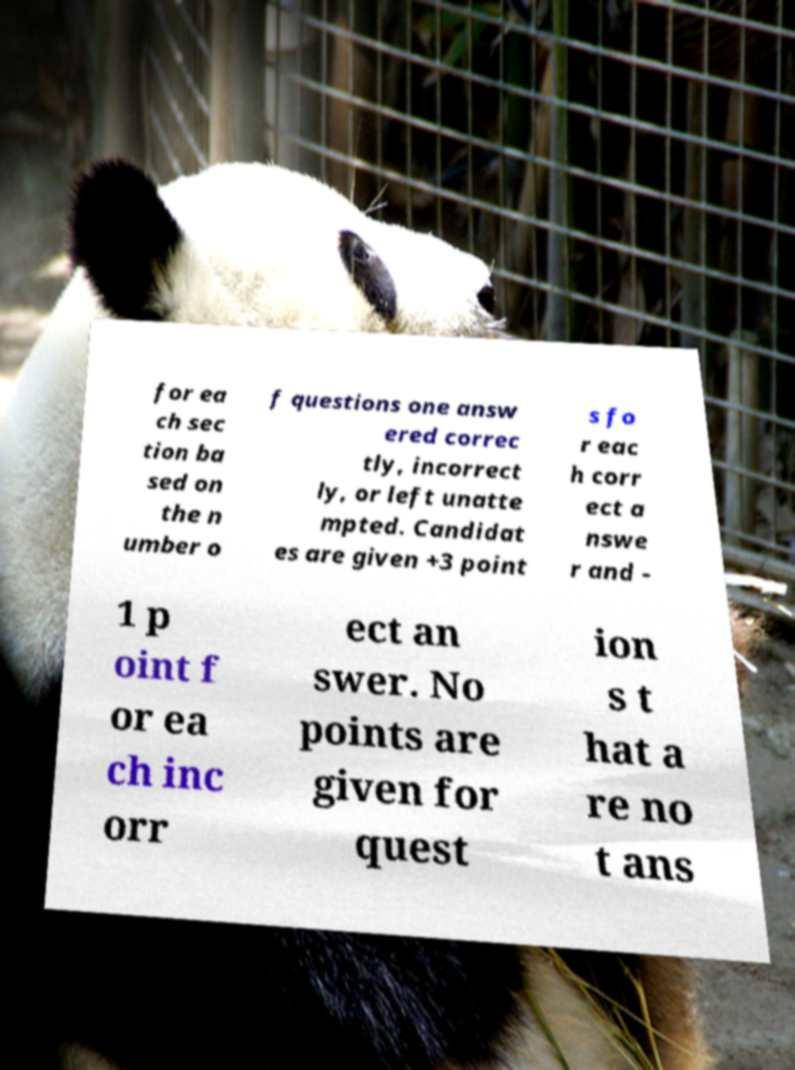Can you accurately transcribe the text from the provided image for me? for ea ch sec tion ba sed on the n umber o f questions one answ ered correc tly, incorrect ly, or left unatte mpted. Candidat es are given +3 point s fo r eac h corr ect a nswe r and - 1 p oint f or ea ch inc orr ect an swer. No points are given for quest ion s t hat a re no t ans 